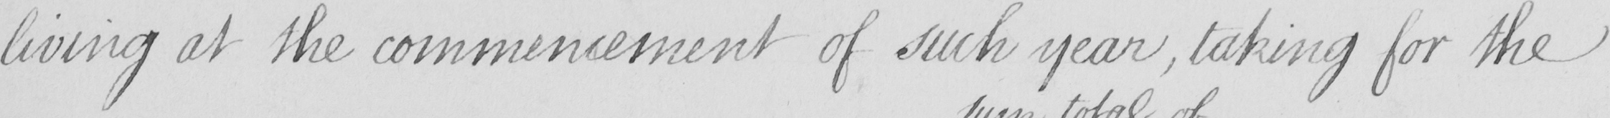What text is written in this handwritten line? living at the commencement of such year  , taking for the 